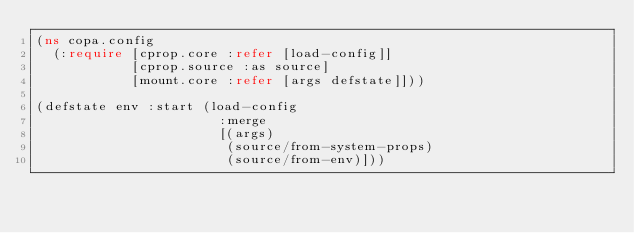Convert code to text. <code><loc_0><loc_0><loc_500><loc_500><_Clojure_>(ns copa.config
  (:require [cprop.core :refer [load-config]]
            [cprop.source :as source]
            [mount.core :refer [args defstate]]))

(defstate env :start (load-config
                       :merge
                       [(args)
                        (source/from-system-props)
                        (source/from-env)]))

</code> 